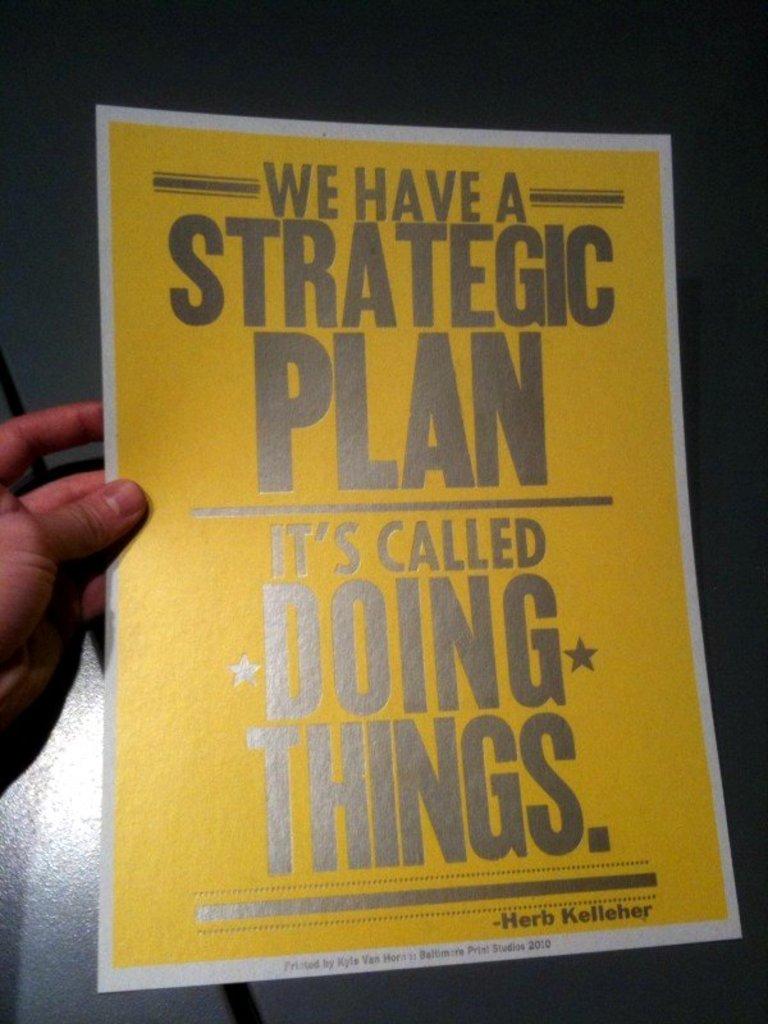Who is the flier by?
Provide a short and direct response. Herb kelleher. What is it called?
Your answer should be compact. Doing things. 